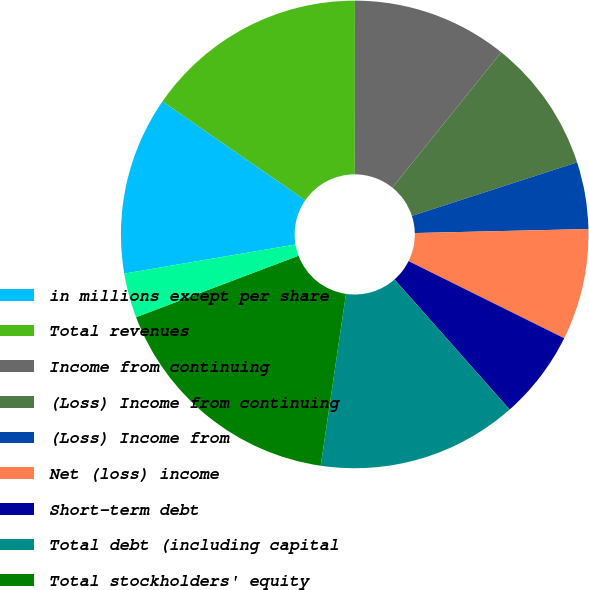<chart> <loc_0><loc_0><loc_500><loc_500><pie_chart><fcel>in millions except per share<fcel>Total revenues<fcel>Income from continuing<fcel>(Loss) Income from continuing<fcel>(Loss) Income from<fcel>Net (loss) income<fcel>Short-term debt<fcel>Total debt (including capital<fcel>Total stockholders' equity<fcel>Basic<nl><fcel>12.31%<fcel>15.38%<fcel>10.77%<fcel>9.23%<fcel>4.62%<fcel>7.69%<fcel>6.15%<fcel>13.85%<fcel>16.92%<fcel>3.08%<nl></chart> 